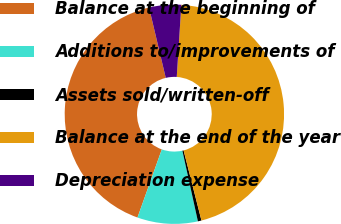Convert chart to OTSL. <chart><loc_0><loc_0><loc_500><loc_500><pie_chart><fcel>Balance at the beginning of<fcel>Additions to/improvements of<fcel>Assets sold/written-off<fcel>Balance at the end of the year<fcel>Depreciation expense<nl><fcel>40.83%<fcel>8.9%<fcel>0.53%<fcel>45.02%<fcel>4.72%<nl></chart> 